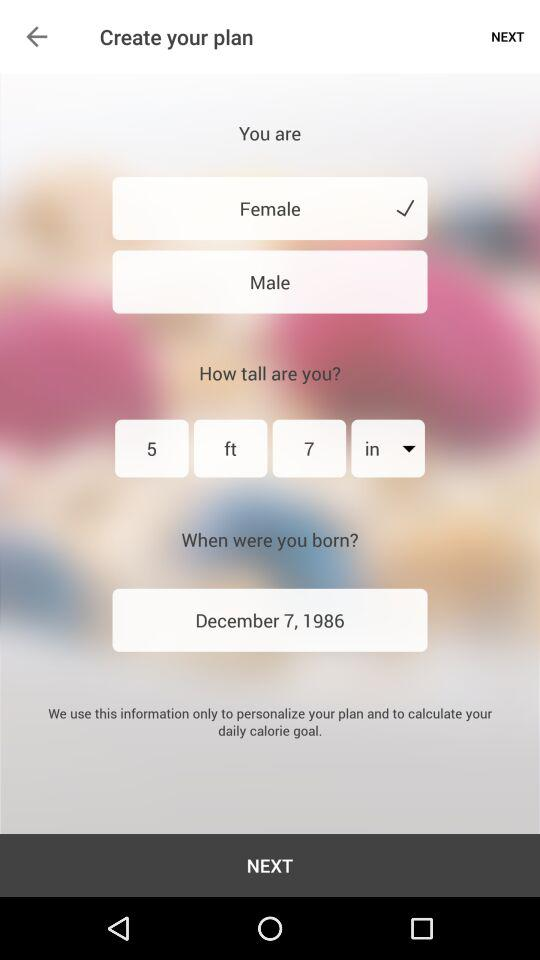How many options are there for gender?
Answer the question using a single word or phrase. 2 